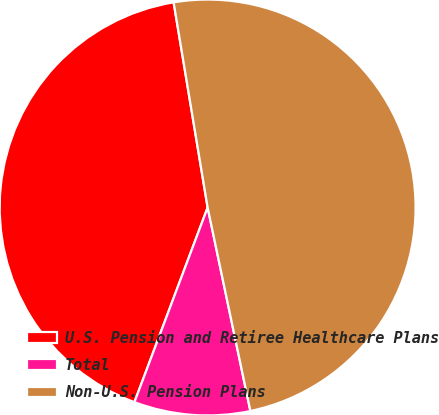Convert chart to OTSL. <chart><loc_0><loc_0><loc_500><loc_500><pie_chart><fcel>U.S. Pension and Retiree Healthcare Plans<fcel>Total<fcel>Non-U.S. Pension Plans<nl><fcel>41.66%<fcel>9.02%<fcel>49.32%<nl></chart> 